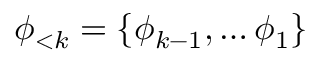Convert formula to latex. <formula><loc_0><loc_0><loc_500><loc_500>\phi _ { < k } = \{ \phi _ { k - 1 } , \dots \phi _ { 1 } \}</formula> 